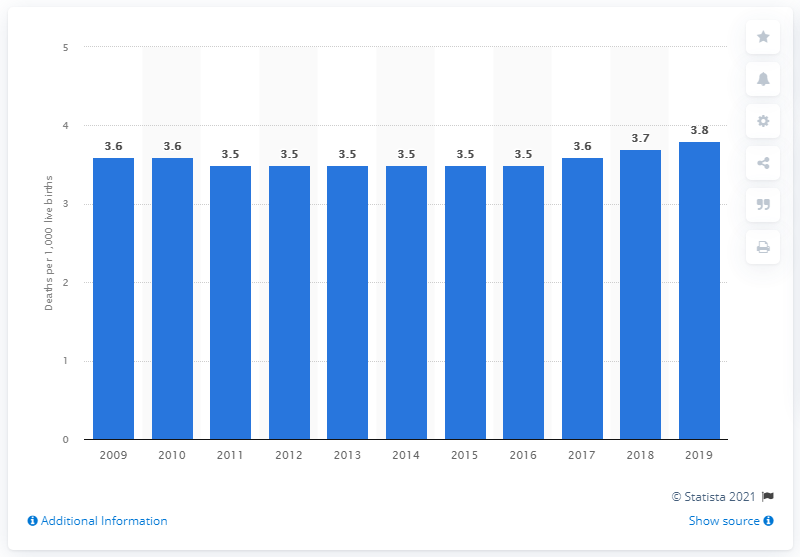Highlight a few significant elements in this photo. In 2019, the infant mortality rate in France was 3.8 per 1,000 live births. 